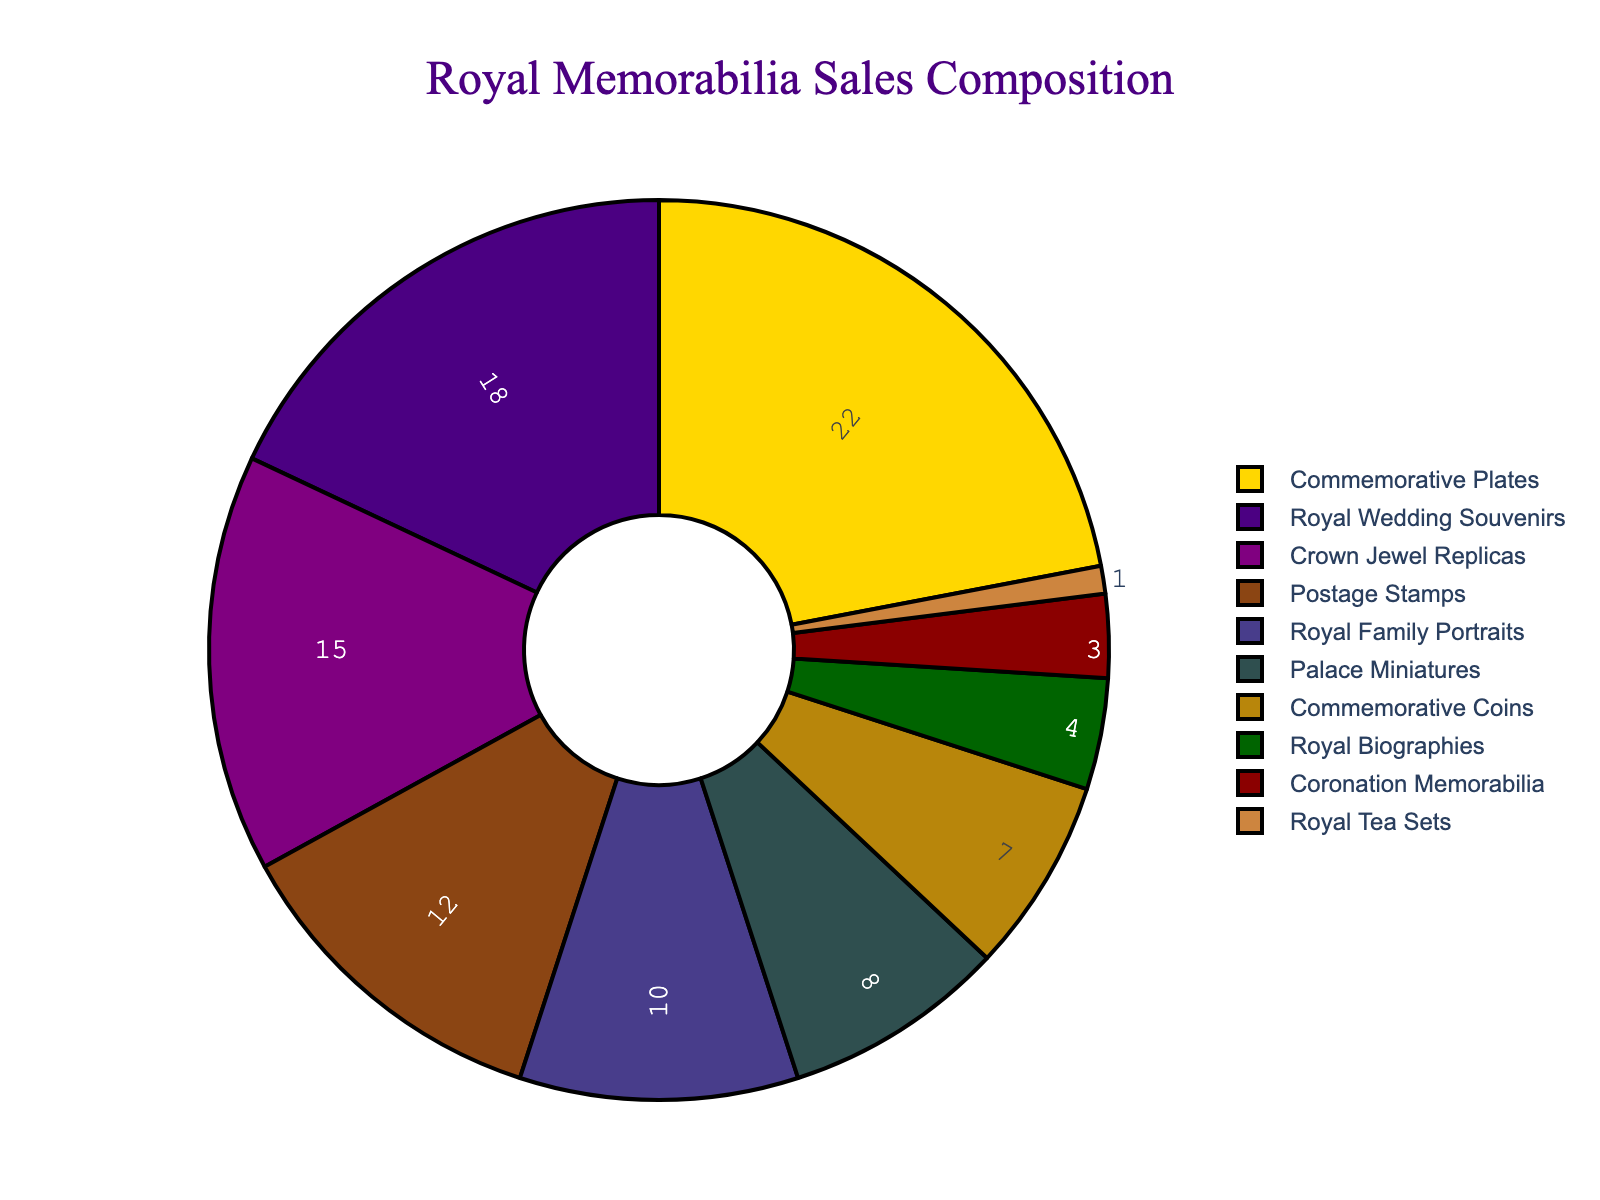What product category has the highest percentage of sales? The product category with the highest percentage can be determined directly by looking at the largest segment in the pie chart. This segment represents 22% of sales.
Answer: Commemorative Plates How much more percentage do Commemorative Plates have compared to Royal Wedding Souvenirs? First, find the percentages for Commemorative Plates (22%) and Royal Wedding Souvenirs (18%). Then subtract the percentage of Royal Wedding Souvenirs from that of Commemorative Plates: 22% - 18% = 4%.
Answer: 4% What is the combined percentage of Crown Jewel Replicas and Royal Family Portraits? Identify the individual percentages for Crown Jewel Replicas (15%) and Royal Family Portraits (10%), then add these percentages together: 15% + 10% = 25%.
Answer: 25% Which product category contributes the least to the sales? The product category contributing the least can be found by identifying the smallest segment in the pie chart, which represents 1% of sales.
Answer: Royal Tea Sets How does the percentage of Postage Stamps compare to that of Palace Miniatures? The percentage for Postage Stamps is 12%, while for Palace Miniatures it is 8%. Comparing these, Postage Stamps have a higher percentage than Palace Miniatures by 4%.
Answer: Postage Stamps have 4% more What is the total percentage for categories that are under 10%? Identify the categories under 10%: Palace Miniatures (8%), Commemorative Coins (7%), Royal Biographies (4%), Coronation Memorabilia (3%), and Royal Tea Sets (1%). Sum these percentages: 8% + 7% + 4% + 3% + 1% = 23%.
Answer: 23% What is the difference in percentage between the highest and lowest category? The highest category is Commemorative Plates at 22%, and the lowest is Royal Tea Sets at 1%. Subtract the percentage of Royal Tea Sets from that of Commemorative Plates: 22% - 1% = 21%.
Answer: 21% Which product categories have a sales percentage lower than Royal Wedding Souvenirs but higher than Royal Tea Sets? Identify the percentage of Royal Wedding Souvenirs (18%) and Royal Tea Sets (1%). The categories that fall in between are Crown Jewel Replicas (15%), Postage Stamps (12%), Royal Family Portraits (10%), Palace Miniatures (8%), Commemorative Coins (7%), Royal Biographies (4%), and Coronation Memorabilia (3%).
Answer: Crown Jewel Replicas, Postage Stamps, Royal Family Portraits, Palace Miniatures, Commemorative Coins, Royal Biographies, Coronation Memorabilia Which two categories combined give a percentage equal to Commemorative Plates? Commemorative Plates have a percentage of 22%. Combining Royal Wedding Souvenirs (18%) and Royal Biographies (4%) gives us: 18% + 4% = 22%.
Answer: Royal Wedding Souvenirs and Royal Biographies What is the average percentage of the top three product categories? The top three categories are Commemorative Plates (22%), Royal Wedding Souvenirs (18%), and Crown Jewel Replicas (15%). Calculate the total: 22% + 18% + 15% = 55%, then divide by the number of categories: 55% / 3 ≈ 18.33%.
Answer: 18.33% 